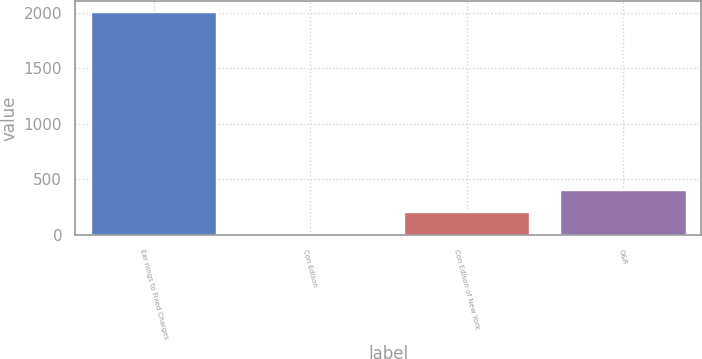Convert chart to OTSL. <chart><loc_0><loc_0><loc_500><loc_500><bar_chart><fcel>Ear nings to Fixed Charges<fcel>Con Edison<fcel>Con Edison of New York<fcel>O&R<nl><fcel>2003<fcel>2.7<fcel>202.73<fcel>402.76<nl></chart> 